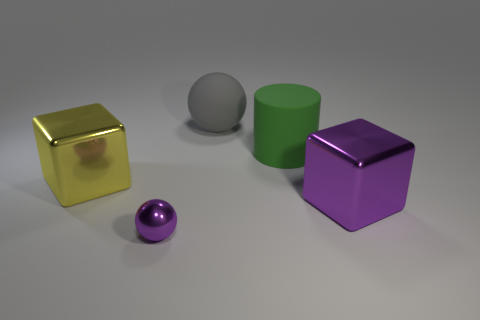The big shiny cube that is to the right of the big metal block behind the big block that is in front of the yellow object is what color?
Ensure brevity in your answer.  Purple. Are there fewer large rubber balls than shiny objects?
Provide a succinct answer. Yes. There is a large object that is the same shape as the small purple object; what is its color?
Offer a very short reply. Gray. There is a object that is made of the same material as the green cylinder; what is its color?
Your response must be concise. Gray. What number of other green rubber cylinders are the same size as the green rubber cylinder?
Ensure brevity in your answer.  0. What material is the large green object?
Offer a terse response. Rubber. Are there more tiny purple shiny spheres than big yellow shiny cylinders?
Keep it short and to the point. Yes. Do the tiny purple thing and the large gray matte object have the same shape?
Offer a very short reply. Yes. Is there anything else that is the same shape as the large yellow metallic thing?
Your response must be concise. Yes. There is a cube on the right side of the yellow block; is its color the same as the ball in front of the green object?
Your answer should be compact. Yes. 